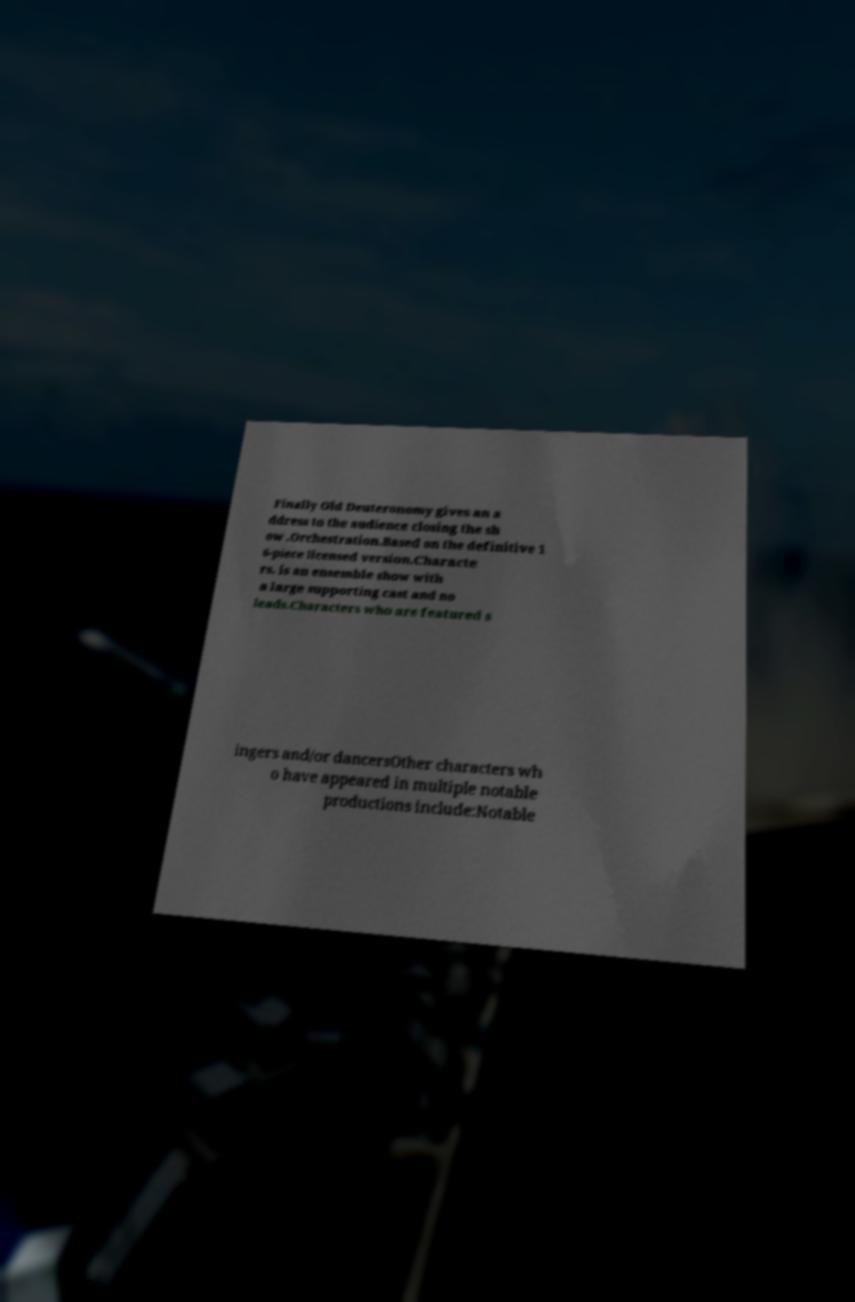I need the written content from this picture converted into text. Can you do that? Finally Old Deuteronomy gives an a ddress to the audience closing the sh ow .Orchestration.Based on the definitive 1 6-piece licensed version.Characte rs. is an ensemble show with a large supporting cast and no leads.Characters who are featured s ingers and/or dancersOther characters wh o have appeared in multiple notable productions include:Notable 